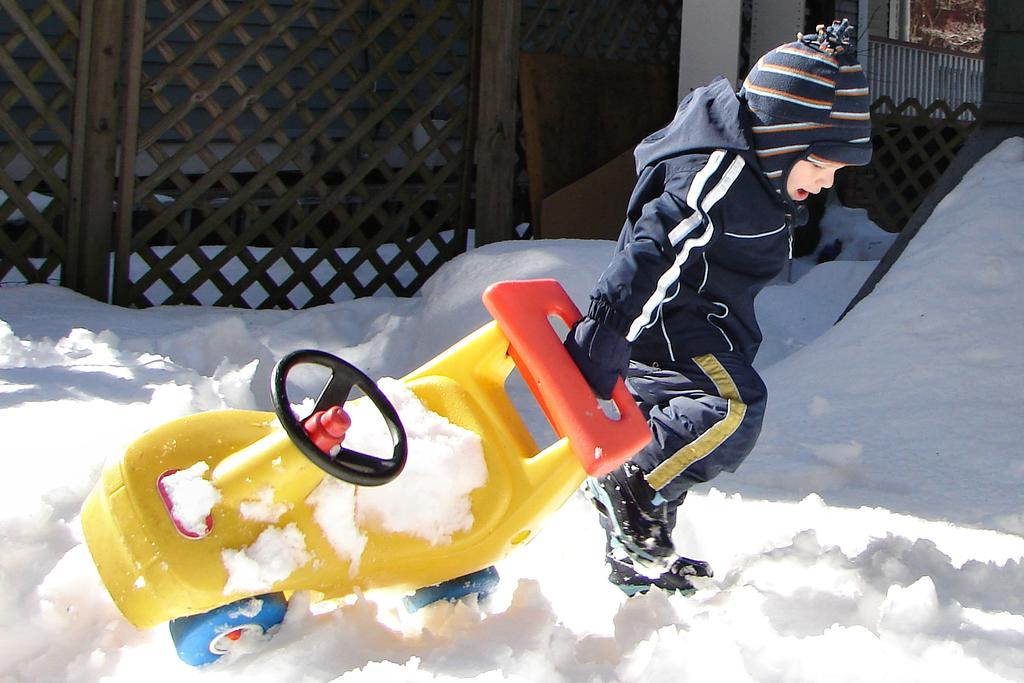Who is present in the image? There is a boy in the image. What is the boy holding in the image? The boy is holding a vehicle. What type of weather is depicted in the image? There is snow on the surface at the bottom of the image. What type of structure can be seen in the image? There is a fence and a building in the image. Where is the nest located in the image? There is no nest present in the image. Can you describe the board that the boy is standing on in the image? There is no board mentioned in the image; the boy is standing on snow. 